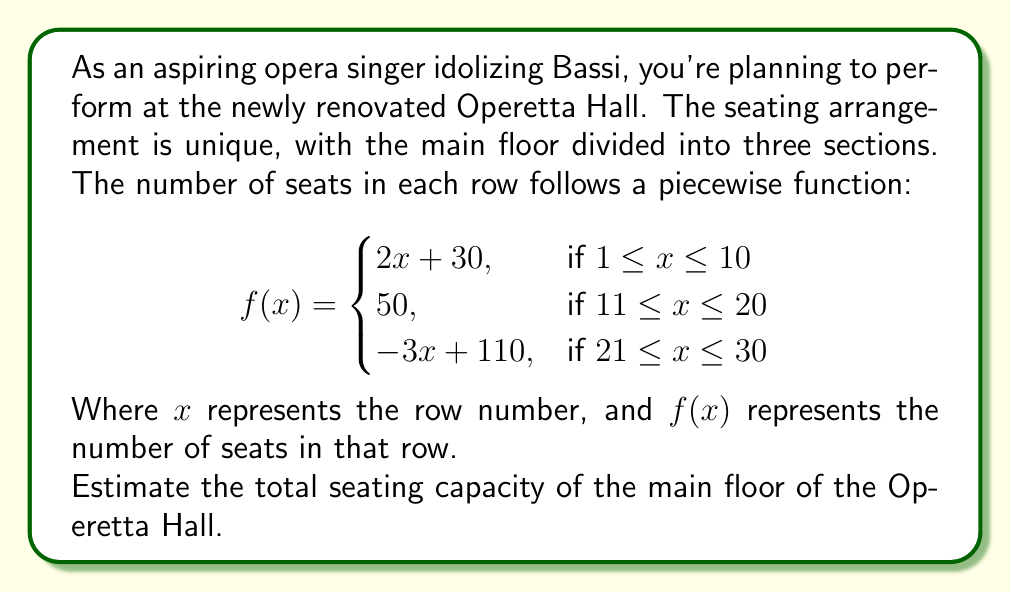What is the answer to this math problem? To estimate the total seating capacity, we need to calculate the sum of seats in all rows using the given piecewise function. Let's break it down by sections:

1. Section 1 (rows 1-10):
   Use the formula $2x + 30$ for each row
   Sum = $\sum_{x=1}^{10} (2x + 30)$
   $= 2 \cdot \frac{10(10+1)}{2} + 30 \cdot 10 = 110 + 300 = 410$ seats

2. Section 2 (rows 11-20):
   Each row has 50 seats
   Sum = $50 \cdot 10 = 500$ seats

3. Section 3 (rows 21-30):
   Use the formula $-3x + 110$ for each row
   Sum = $\sum_{x=21}^{30} (-3x + 110)$
   $= -3 \cdot \frac{10(51)}{2} + 110 \cdot 10 = -765 + 1100 = 335$ seats

Total estimated capacity:
$410 + 500 + 335 = 1245$ seats
Answer: The estimated total seating capacity of the main floor of the Operetta Hall is 1245 seats. 